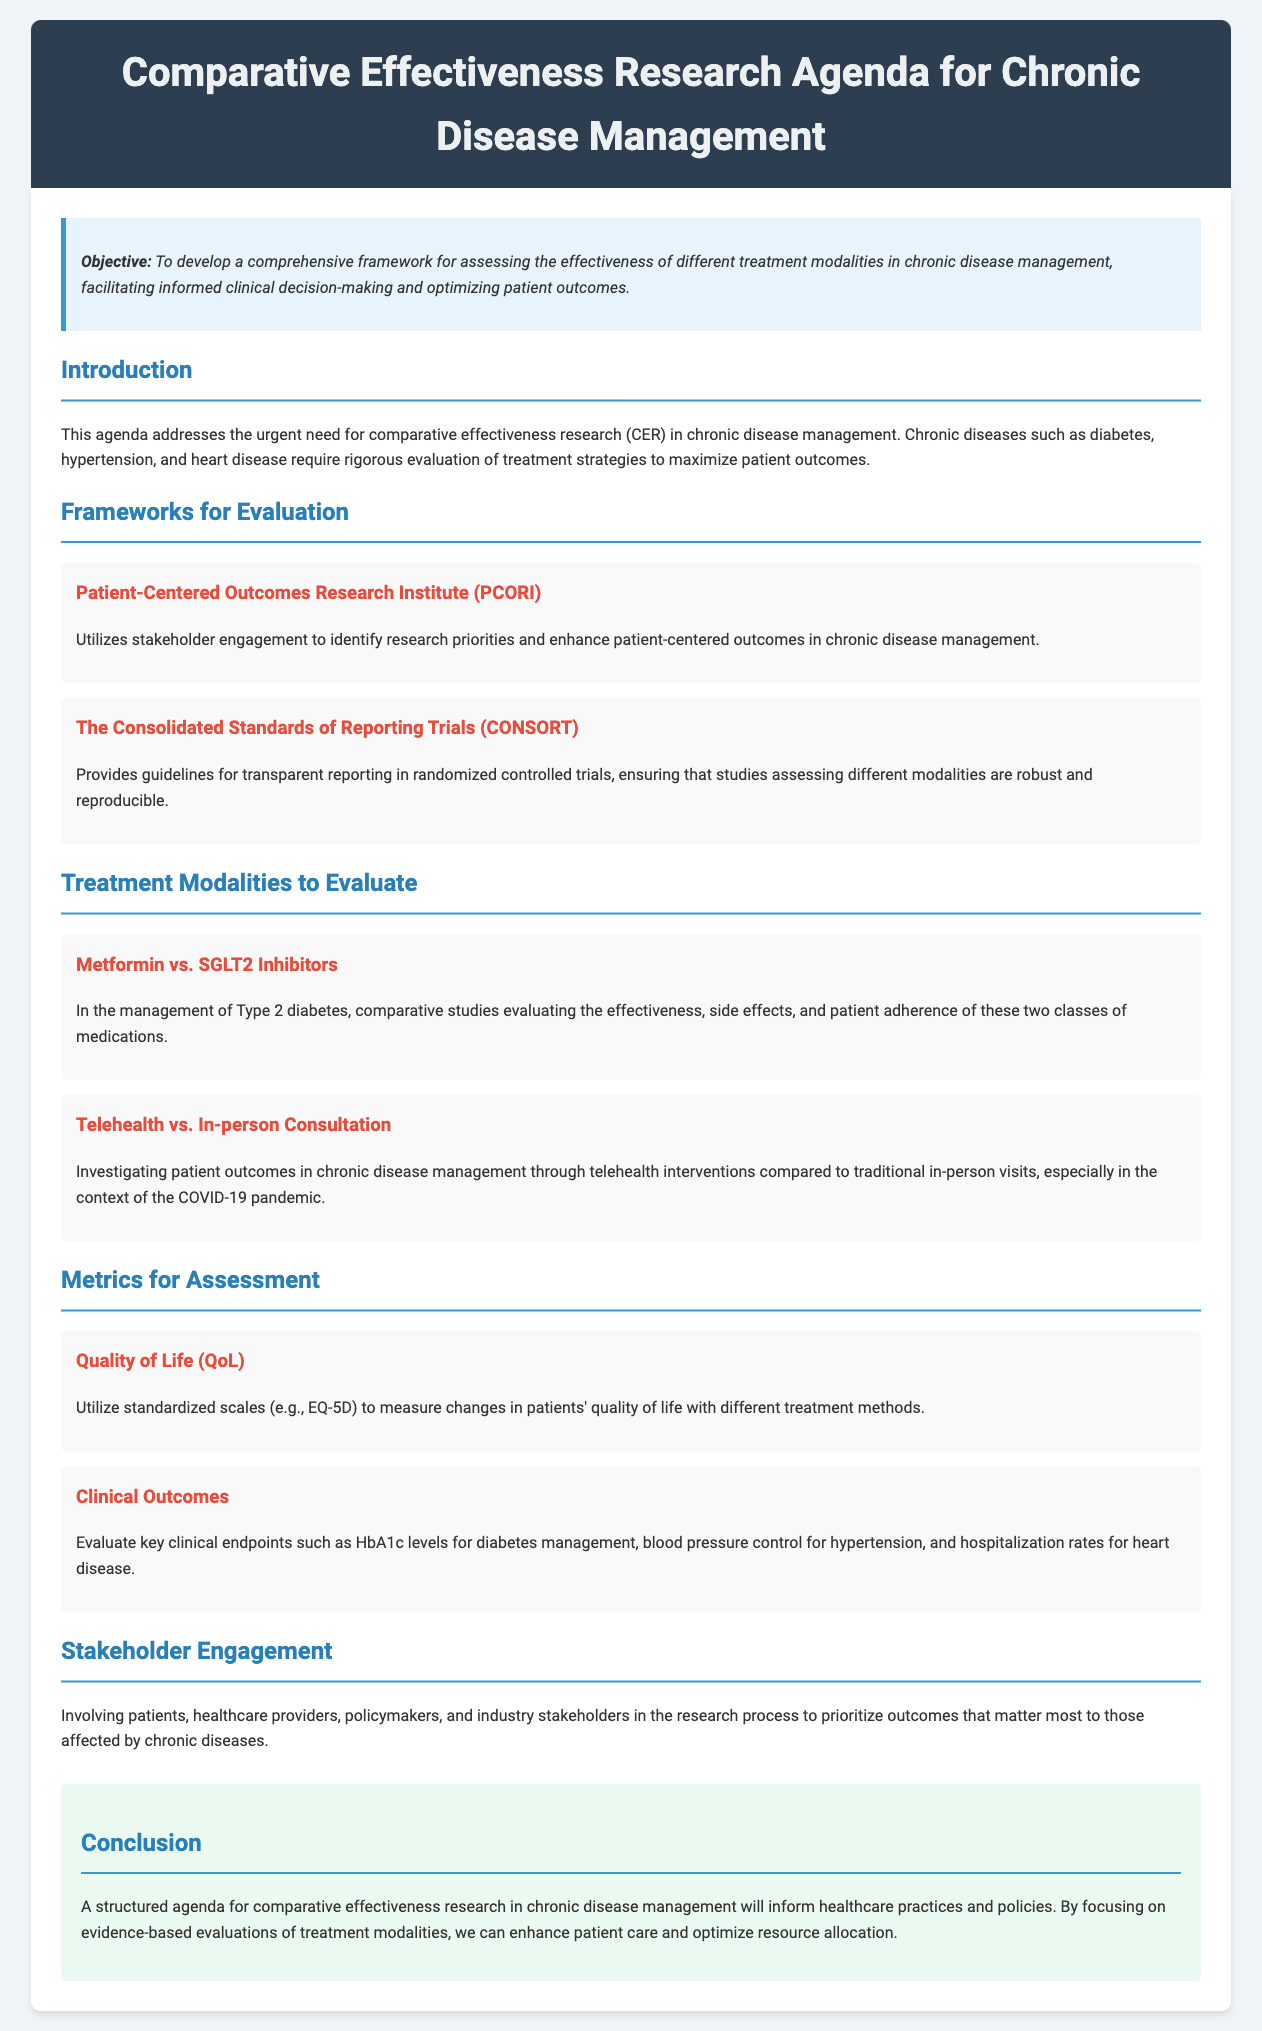What is the primary objective of the agenda? The primary objective of the agenda is to develop a comprehensive framework for assessing the effectiveness of different treatment modalities in chronic disease management.
Answer: To develop a comprehensive framework for assessing the effectiveness of different treatment modalities in chronic disease management What organization is mentioned as utilizing stakeholder engagement? The document mentions the Patient-Centered Outcomes Research Institute, which uses stakeholder engagement to identify research priorities.
Answer: Patient-Centered Outcomes Research Institute (PCORI) Which treatment modality is evaluated against Metformin? The agenda discusses the evaluation of SGLT2 Inhibitors in comparison to Metformin for Type 2 diabetes management.
Answer: SGLT2 Inhibitors What metric is used to measure changes in patients' quality of life? The agenda specifies using standardized scales like EQ-5D to measure changes in quality of life.
Answer: EQ-5D What type of consultation is compared to telehealth? The agenda compares telehealth interventions to traditional in-person consultations in chronic disease management.
Answer: In-person Consultation Which chronic disease management is associated with HbA1c levels? The management of Type 2 diabetes is associated with evaluating HbA1c levels as a clinical outcome.
Answer: Type 2 diabetes What is the conclusion about the structured agenda? The conclusion states that a structured agenda for comparative effectiveness research will inform healthcare practices and policies.
Answer: To inform healthcare practices and policies How many frameworks for evaluation are mentioned in the document? The document mentions two frameworks for evaluation: PCORI and CONSORT.
Answer: Two 